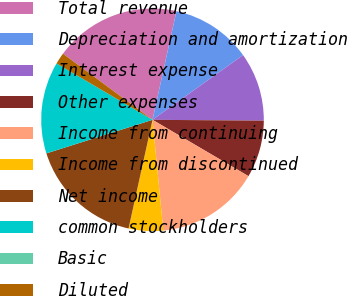<chart> <loc_0><loc_0><loc_500><loc_500><pie_chart><fcel>Total revenue<fcel>Depreciation and amortization<fcel>Interest expense<fcel>Other expenses<fcel>Income from continuing<fcel>Income from discontinued<fcel>Net income<fcel>common stockholders<fcel>Basic<fcel>Diluted<nl><fcel>18.33%<fcel>11.67%<fcel>10.0%<fcel>8.33%<fcel>15.0%<fcel>5.0%<fcel>16.67%<fcel>13.33%<fcel>0.0%<fcel>1.67%<nl></chart> 